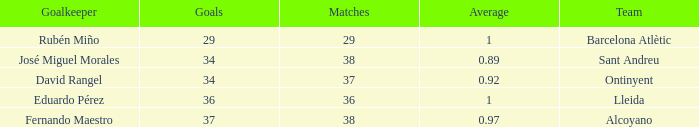What is the sum of Goals, when Matches is less than 29? None. 